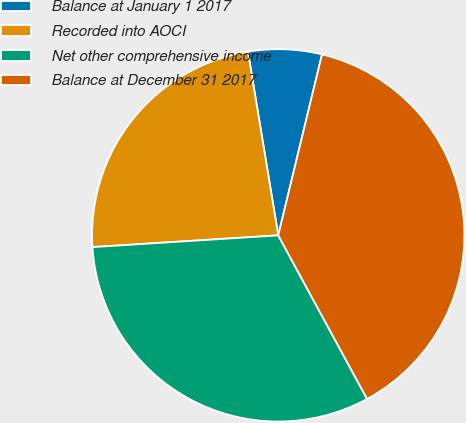Convert chart. <chart><loc_0><loc_0><loc_500><loc_500><pie_chart><fcel>Balance at January 1 2017<fcel>Recorded into AOCI<fcel>Net other comprehensive income<fcel>Balance at December 31 2017<nl><fcel>6.38%<fcel>23.4%<fcel>31.91%<fcel>38.3%<nl></chart> 